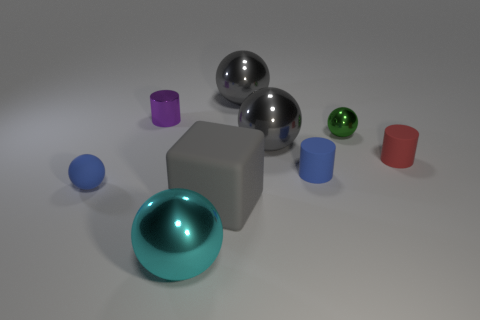What size is the blue rubber object that is the same shape as the big cyan object? The blue rubber object, which shares its spherical shape with the larger cyan sphere in the image, is small in size, similar in dimension to the smaller spheres and cylindrical objects present. 